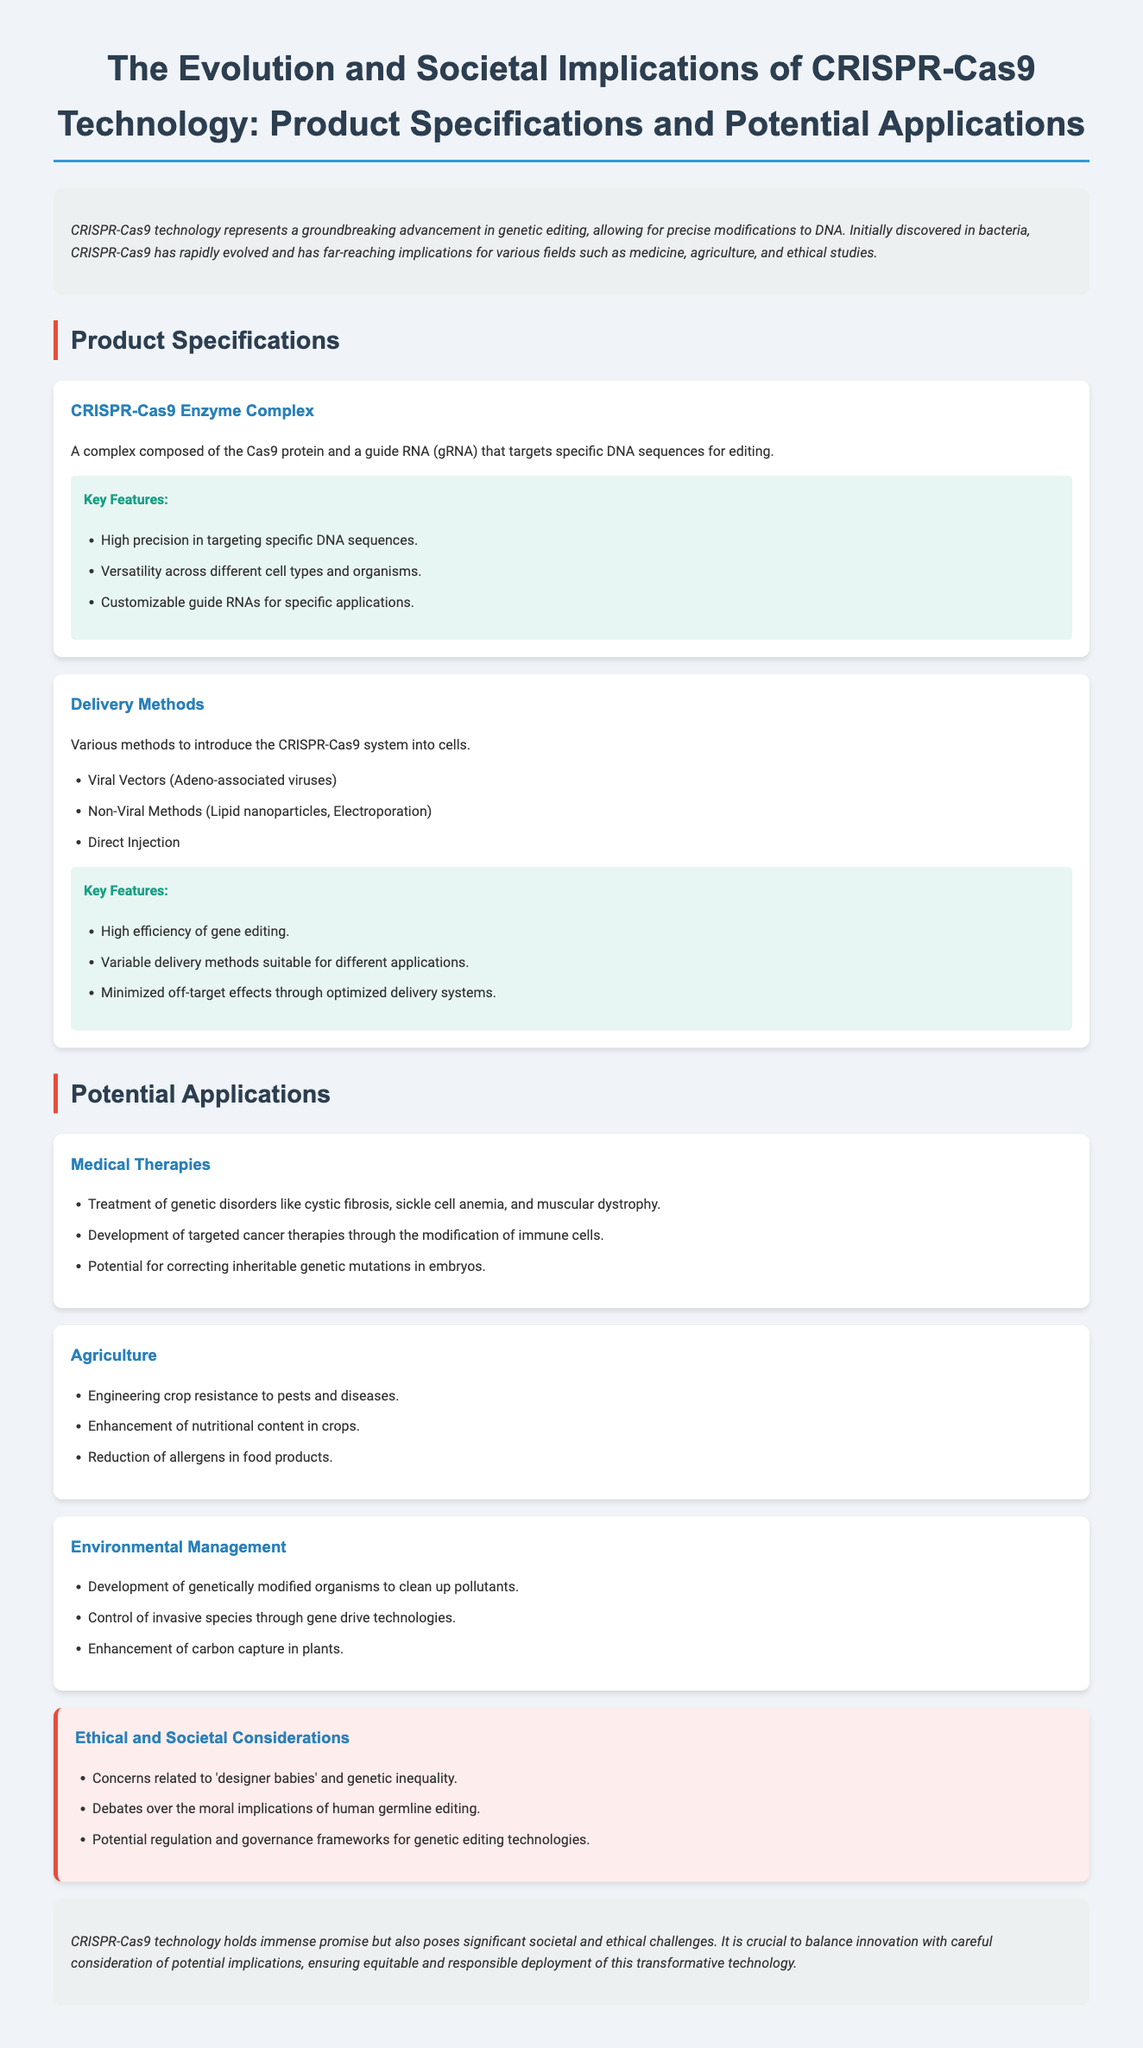What is the main purpose of CRISPR-Cas9 technology? The main purpose of CRISPR-Cas9 technology is to allow for precise modifications to DNA.
Answer: Precise modifications to DNA What does the CRISPR-Cas9 enzyme complex consist of? The CRISPR-Cas9 enzyme complex consists of the Cas9 protein and a guide RNA (gRNA).
Answer: Cas9 protein and a guide RNA Name one delivery method for the CRISPR-Cas9 system. The document lists three delivery methods: Viral Vectors, Non-Viral Methods, and Direct Injection. One example is Viral Vectors.
Answer: Viral Vectors What is a potential application of CRISPR-Cas9 in agriculture? Potential applications in agriculture include engineering crop resistance to pests and diseases.
Answer: Engineering crop resistance to pests and diseases List one ethical concern associated with CRISPR-Cas9 technology. The document mentions concerns related to 'designer babies' and genetic inequality as an ethical concern.
Answer: 'Designer babies' and genetic inequality How does CRISPR-Cas9 technology impact environmental management? CRISPR-Cas9 technology impacts environmental management by developing genetically modified organisms to clean up pollutants.
Answer: Developing genetically modified organisms to clean up pollutants What are the key features of the CRISPR-Cas9 enzyme complex? The key features include high precision in targeting specific DNA sequences, versatility across different cell types and organisms, and customizable guide RNAs.
Answer: High precision, versatility, customizable guide RNAs What is the significance of the ethical section in this document? The ethical section highlights societal considerations and debates regarding CRISPR-Cas9 technology, emphasizing the need for regulation and governance.
Answer: Societal considerations and debates How many genetic disorders are mentioned as treatable with medical therapies from CRISPR-Cas9? The document lists three specific genetic disorders: cystic fibrosis, sickle cell anemia, and muscular dystrophy. Therefore, three disorders are mentioned.
Answer: Three disorders 